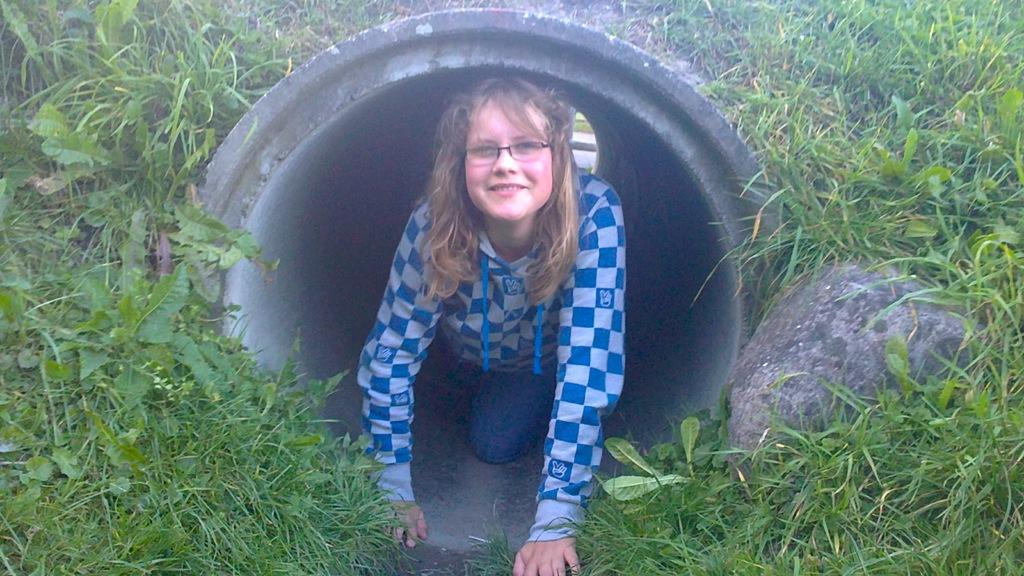Who is the main subject in the image? There is a woman in the center of the image. What is the woman doing in the image? The woman is smiling in the image. Where is the woman located in the image? The woman is inside a pipe in the image. What other objects or elements can be seen in the image? There is a rock on the right side of the image, as well as plants and grass. What type of stretch can be seen in the image? There is no stretch present in the image. What scene is depicted in the image? The image depicts a woman smiling inside a pipe, with a rock, plants, and grass visible. 